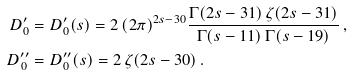<formula> <loc_0><loc_0><loc_500><loc_500>D _ { 0 } ^ { \prime } & = D _ { 0 } ^ { \prime } ( s ) = 2 \, ( 2 \pi ) ^ { 2 s - 3 0 } \frac { \Gamma ( 2 s - 3 1 ) \, \zeta ( 2 s - 3 1 ) } { \Gamma ( s - 1 1 ) \, \Gamma ( s - 1 9 ) } \, , \\ D _ { 0 } ^ { \prime \prime } & = D _ { 0 } ^ { \prime \prime } ( s ) = 2 \, \zeta ( 2 s - 3 0 ) \, .</formula> 